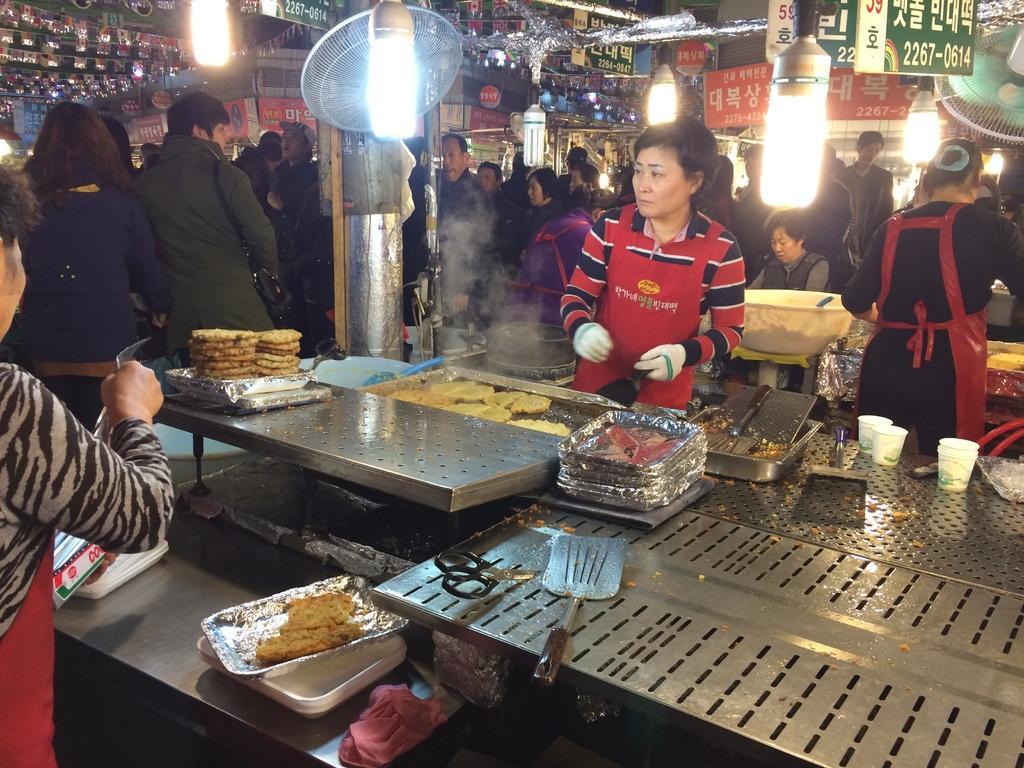How would you summarize this image in a sentence or two? In the picture I can see group of people are standing on the ground. Here I can see food items, scissor, glasses, plates and some other objects on a metal surface. I can also see fans, lights and some other objects. 